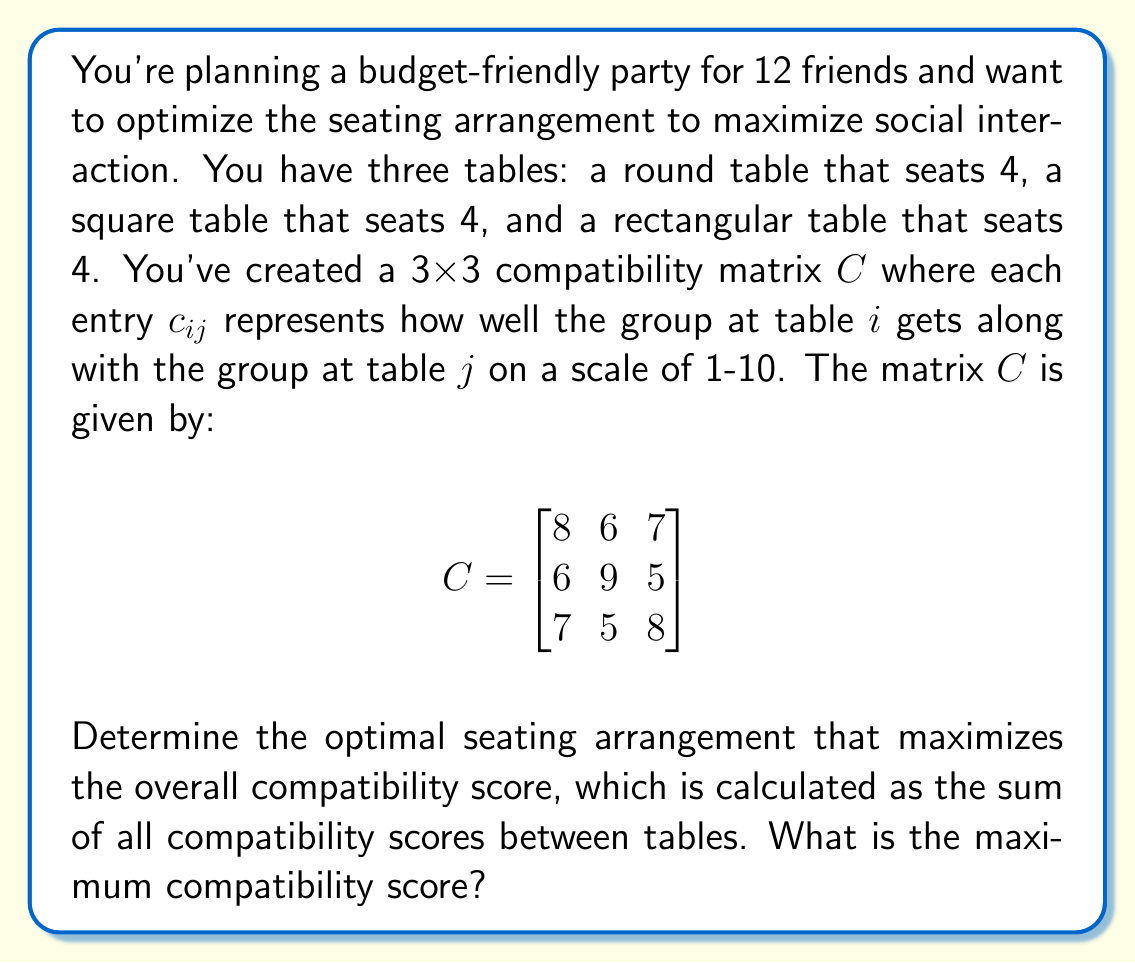Can you answer this question? Let's approach this step-by-step:

1) First, we need to understand what the compatibility matrix $C$ represents. Each entry $c_{ij}$ shows how well the group at table $i$ gets along with the group at table $j$.

2) The diagonal elements ($c_{11}$, $c_{22}$, $c_{33}$) represent how well the people at each table get along with each other.

3) To find the total compatibility score, we need to sum all the elements of the matrix. However, we don't want to double-count the interactions between tables.

4) The sum of all elements in $C$ is:

   $8 + 6 + 7 + 6 + 9 + 5 + 7 + 5 + 8 = 61$

5) But this includes double-counting of inter-table interactions. We need to subtract the duplicate counts:

   $61 - (6 + 7 + 5) = 43$

6) This 43 represents the maximum possible compatibility score for any seating arrangement.

7) To achieve this maximum score, we need to keep the seating arrangement as it is in the given matrix $C$. Any other arrangement would result in a lower score.

8) So, the optimal seating arrangement is:
   - Table 1 (round): Group 1
   - Table 2 (square): Group 2
   - Table 3 (rectangular): Group 3

This arrangement ensures that the groups with the highest compatibility (9) sit together at the square table, while also optimizing the inter-table interactions.
Answer: The maximum compatibility score is 43, achieved by keeping the seating arrangement as represented in the given compatibility matrix $C$. 